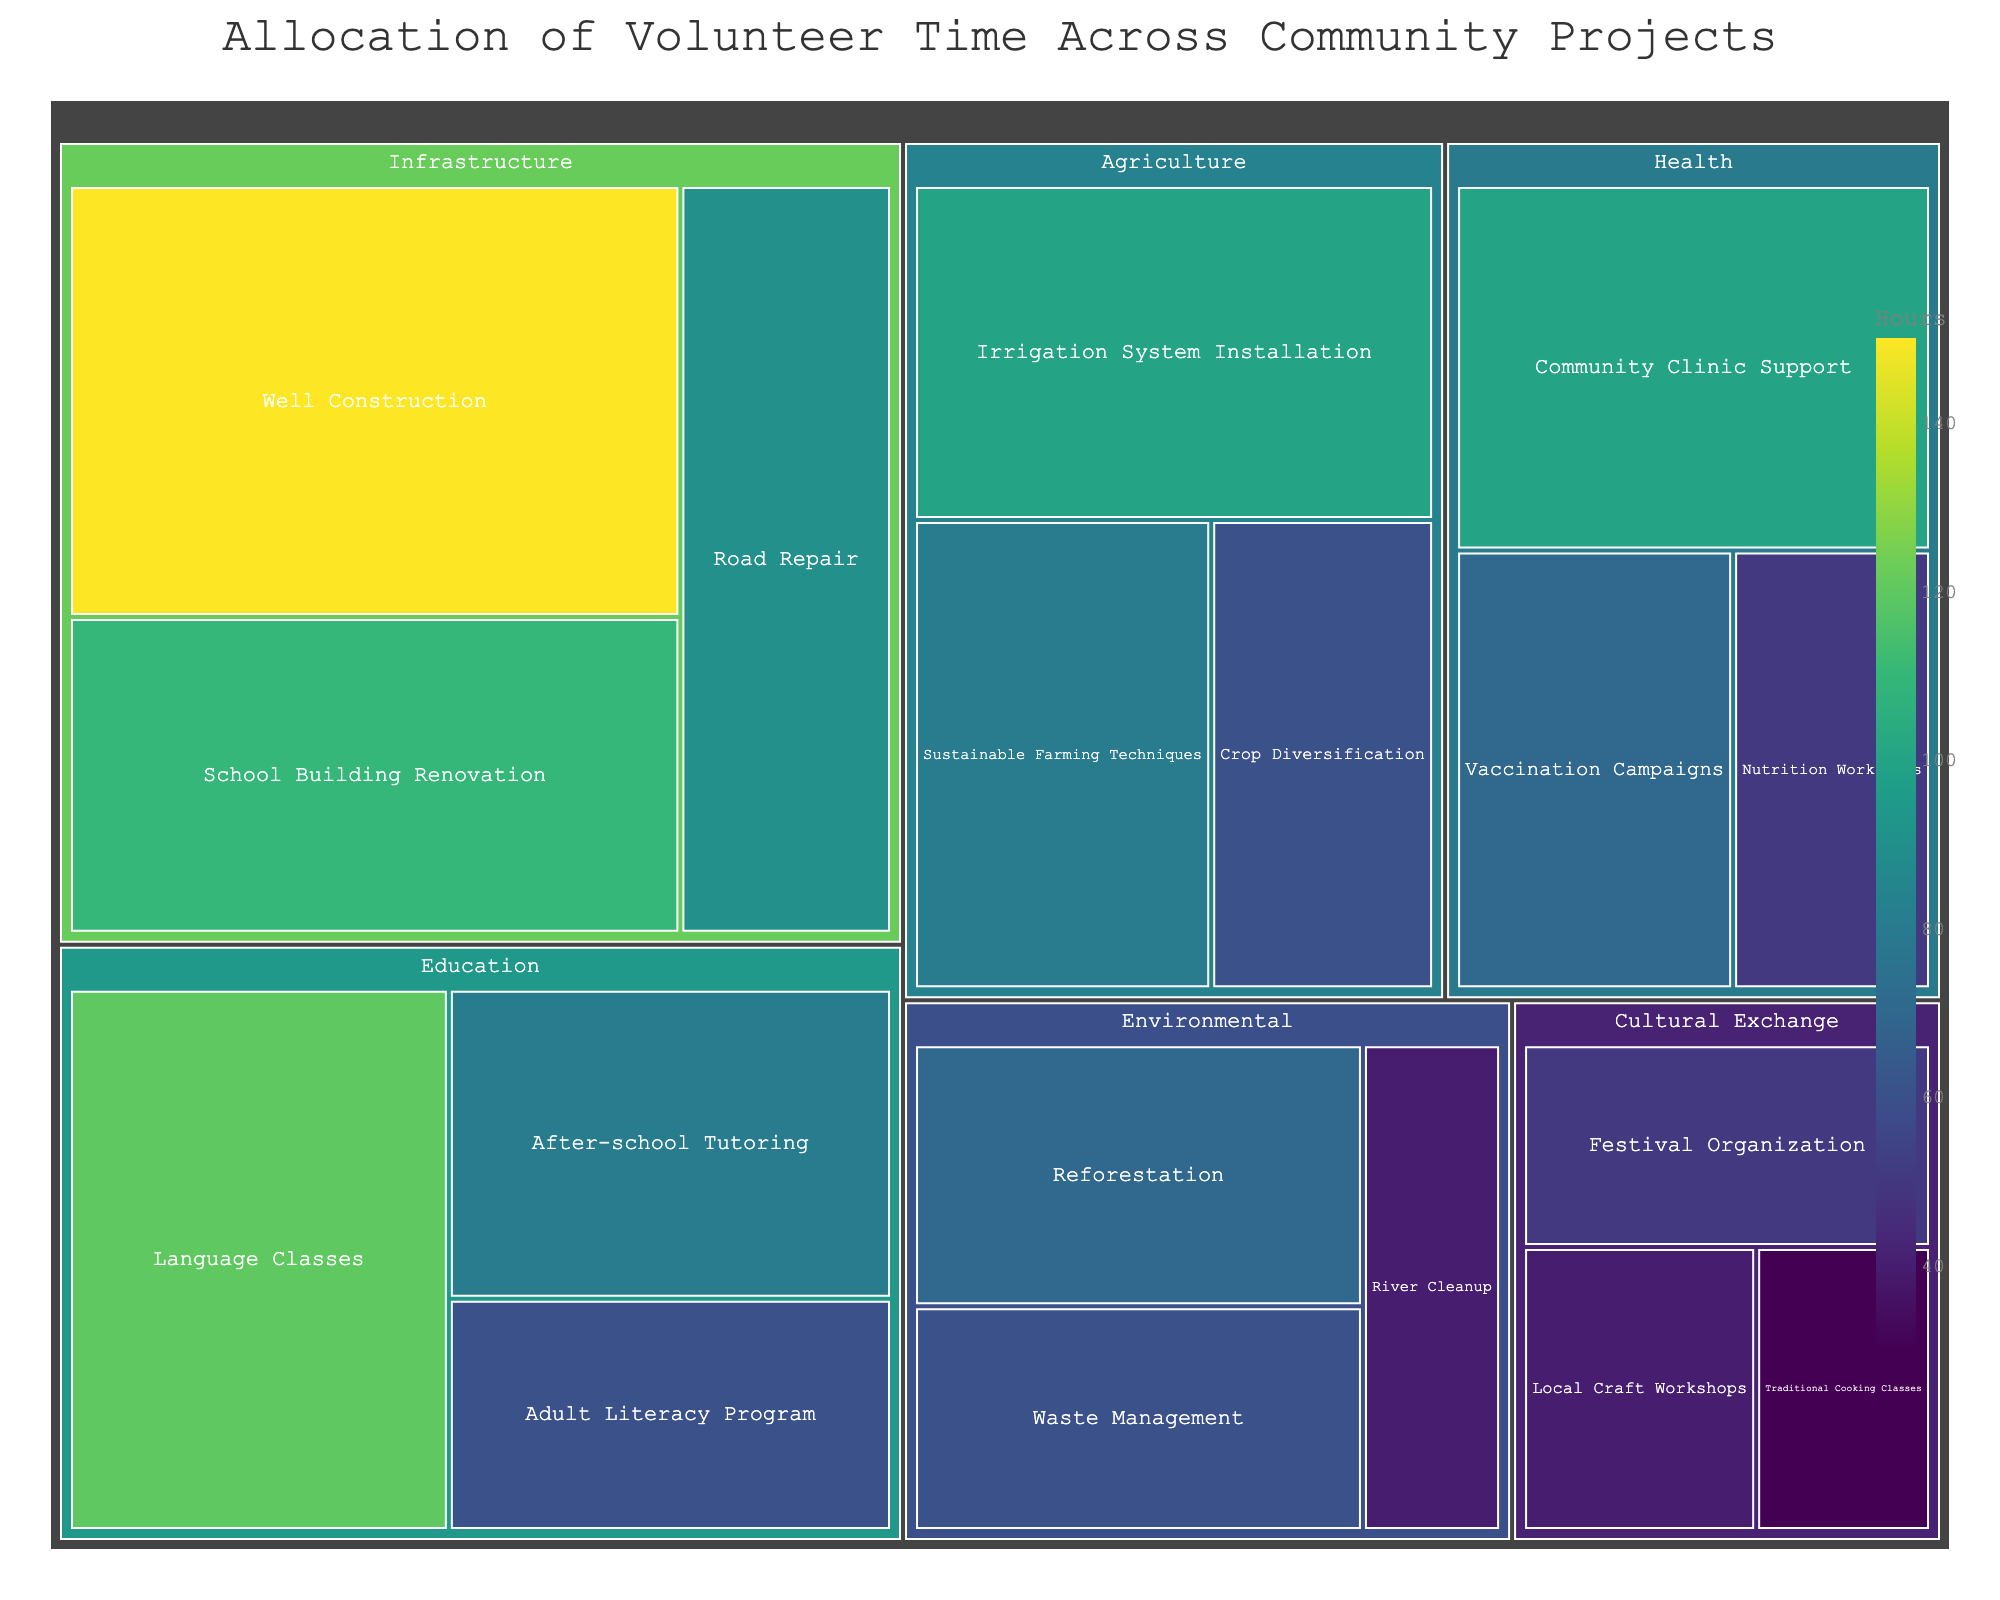What is the title of the treemap? The title of the treemap is usually displayed at the top of the plot. Observing the top area of the figure, you can find the title mentioned.
Answer: Allocation of Volunteer Time Across Community Projects Which category has the highest allocation of hours? To find this, observe the size of the rectangles for each category and identify the largest one. In this case, look for the largest rectangle among the categories.
Answer: Infrastructure How many hours are allocated to 'Vaccination Campaigns'? Locate the project called 'Vaccination Campaigns' within the 'Health' category. The number of hours is directly displayed within that rectangle.
Answer: 70 What is the color scale used for the treemap, and what does it represent? The color scale can be identified by looking at the legend or color bar accompanying the figure. The colors represent the value of the 'Hours' allocated, typically on a continuous gradient.
Answer: Viridis, representing hours Compare the hours allocated to 'Well Construction' and 'School Building Renovation' within the 'Infrastructure' category. Which one has more? Within the 'Infrastructure' category, find the rectangles for 'Well Construction' and 'School Building Renovation'. Compare the values directly shown within each box.
Answer: Well Construction What is the sum of hours allocated to 'Education' and 'Health' categories? Add the hours of all projects within the 'Education' category (120 + 80 + 60) and the 'Health' category (100 + 50 + 70). Compute the total sum.
Answer: 480 Which specific project has the least hours allocated across all categories? Identify the smallest rectangle in the entire treemap. This project will have the lowest hours assigned, shown directly within the box.
Answer: Traditional Cooking Classes How does the 'Agriculture' category compare to 'Environmental' in terms of total hours allocated? Sum the hours of projects within the 'Agriculture' category (80 + 60 + 100) and the 'Environmental' category (70 + 60 + 40). Then compare the total hours.
Answer: Equal (240 hours each) What project within the 'Cultural Exchange' category has the highest hours allocated? Look within the 'Cultural Exchange' category to see which rectangle is the largest and has the highest number of hours displayed.
Answer: Festival Organization Calculate the average hours allocated per project in the 'Environmental' category. Sum the hours of all projects within the 'Environmental' category (70 + 60 + 40) and then divide by the number of projects (3). The average is the total sum divided by the number of data points.
Answer: 56.67 